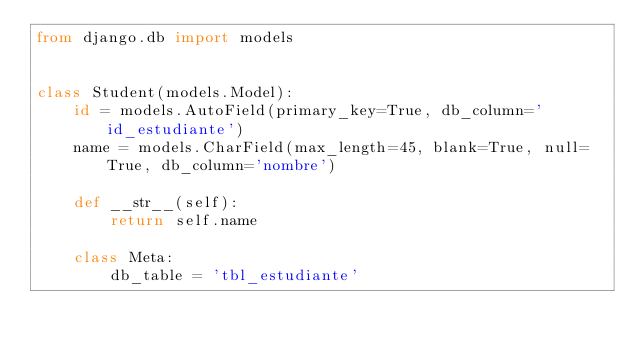Convert code to text. <code><loc_0><loc_0><loc_500><loc_500><_Python_>from django.db import models


class Student(models.Model):
    id = models.AutoField(primary_key=True, db_column='id_estudiante')
    name = models.CharField(max_length=45, blank=True, null=True, db_column='nombre')

    def __str__(self):
        return self.name

    class Meta:
        db_table = 'tbl_estudiante'
</code> 